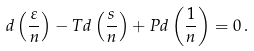<formula> <loc_0><loc_0><loc_500><loc_500>d \left ( \frac { \varepsilon } { n } \right ) - T d \left ( \frac { s } { n } \right ) + P d \left ( \frac { 1 } { n } \right ) = 0 \, .</formula> 